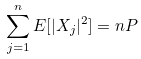Convert formula to latex. <formula><loc_0><loc_0><loc_500><loc_500>\sum _ { j = 1 } ^ { n } E [ | X _ { j } | ^ { 2 } ] = n P</formula> 